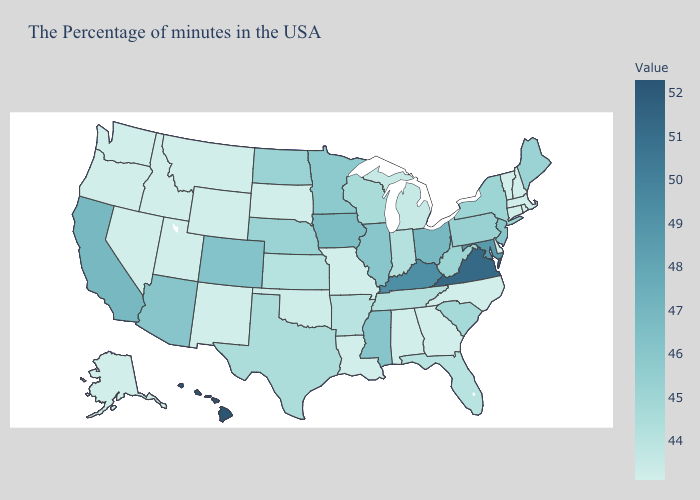Does the map have missing data?
Quick response, please. No. Among the states that border Mississippi , which have the lowest value?
Be succinct. Alabama, Louisiana. Among the states that border Texas , which have the lowest value?
Concise answer only. Louisiana, New Mexico. Which states hav the highest value in the MidWest?
Write a very short answer. Ohio. Is the legend a continuous bar?
Write a very short answer. Yes. 